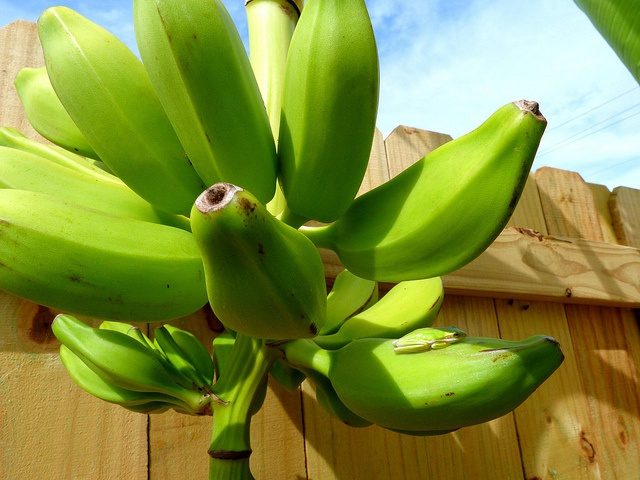Describe the objects in this image and their specific colors. I can see banana in lightblue, darkgreen, olive, green, and khaki tones, banana in lightblue, darkgreen, and olive tones, banana in lightblue, olive, darkgreen, yellow, and green tones, banana in lightblue, darkgreen, and olive tones, and banana in lightblue, yellow, darkgreen, and olive tones in this image. 